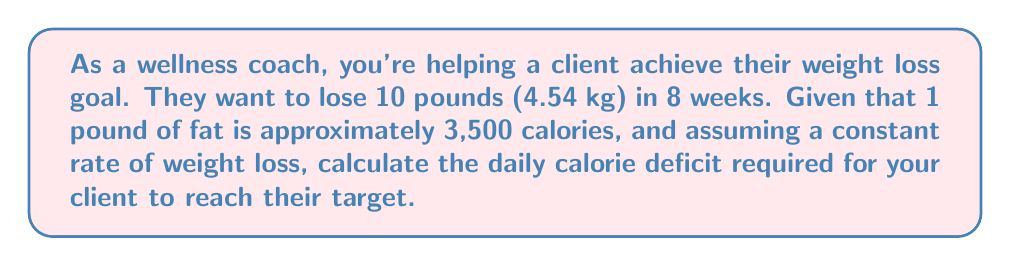Help me with this question. Let's approach this step-by-step:

1. Convert the weight loss goal to calories:
   $$ \text{Total calorie deficit} = 10 \text{ lbs} \times 3,500 \text{ calories/lb} = 35,000 \text{ calories} $$

2. Convert the time frame to days:
   $$ 8 \text{ weeks} \times 7 \text{ days/week} = 56 \text{ days} $$

3. Calculate the daily calorie deficit:
   $$ \text{Daily calorie deficit} = \frac{\text{Total calorie deficit}}{\text{Number of days}} $$
   $$ = \frac{35,000 \text{ calories}}{56 \text{ days}} $$
   $$ = 625 \text{ calories/day} $$

Therefore, to lose 10 pounds in 8 weeks, your client needs to maintain a daily calorie deficit of 625 calories.
Answer: 625 calories/day 